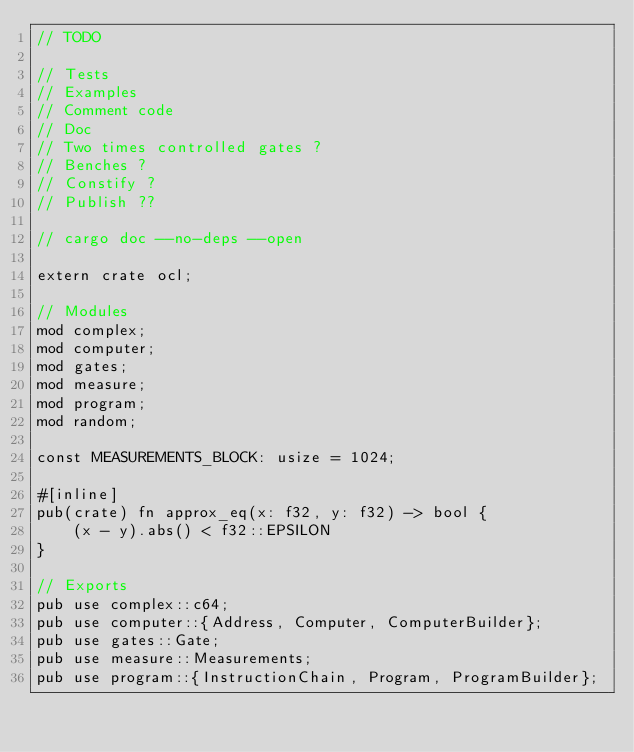<code> <loc_0><loc_0><loc_500><loc_500><_Rust_>// TODO

// Tests
// Examples
// Comment code
// Doc
// Two times controlled gates ?
// Benches ?
// Constify ?
// Publish ??

// cargo doc --no-deps --open

extern crate ocl;

// Modules
mod complex;
mod computer;
mod gates;
mod measure;
mod program;
mod random;

const MEASUREMENTS_BLOCK: usize = 1024;

#[inline]
pub(crate) fn approx_eq(x: f32, y: f32) -> bool {
    (x - y).abs() < f32::EPSILON
}

// Exports
pub use complex::c64;
pub use computer::{Address, Computer, ComputerBuilder};
pub use gates::Gate;
pub use measure::Measurements;
pub use program::{InstructionChain, Program, ProgramBuilder};
</code> 